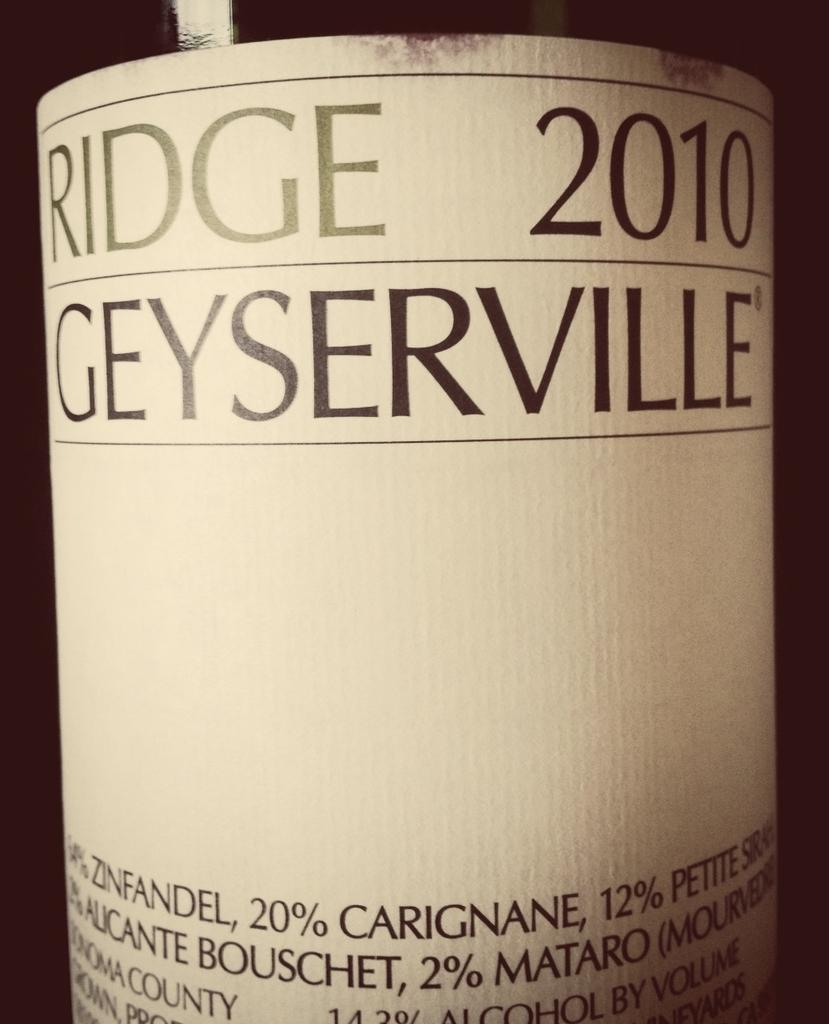<image>
Create a compact narrative representing the image presented. A close up of a bottle of Ridge 2010 Geyserville 